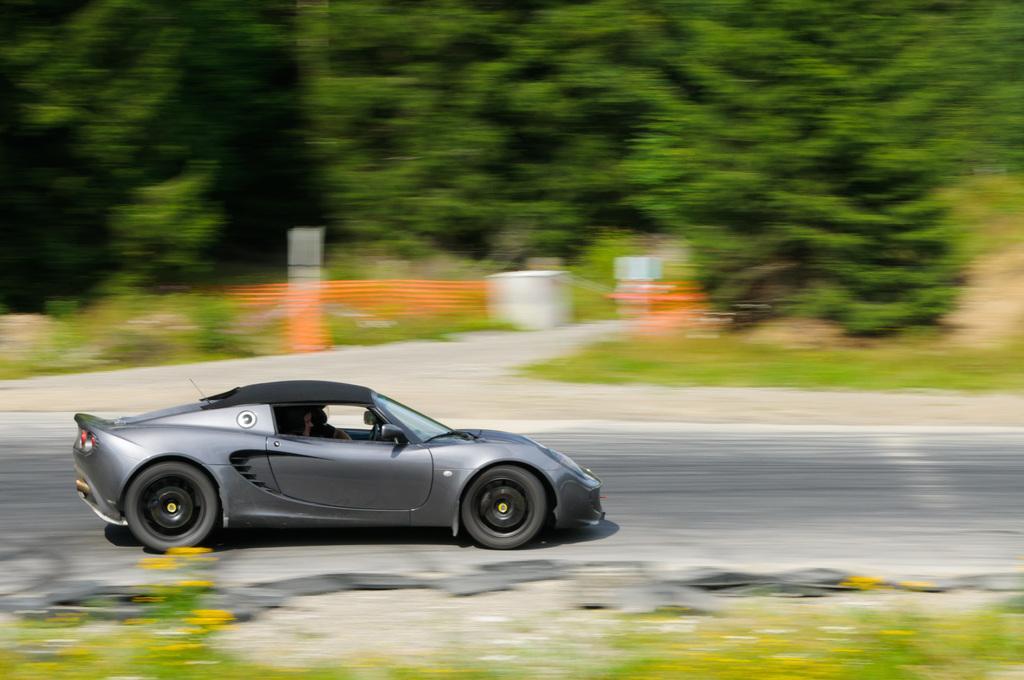In one or two sentences, can you explain what this image depicts? In this image I can see a car on the road. There are trees at the back. The background and foreground of the image is blurred. 